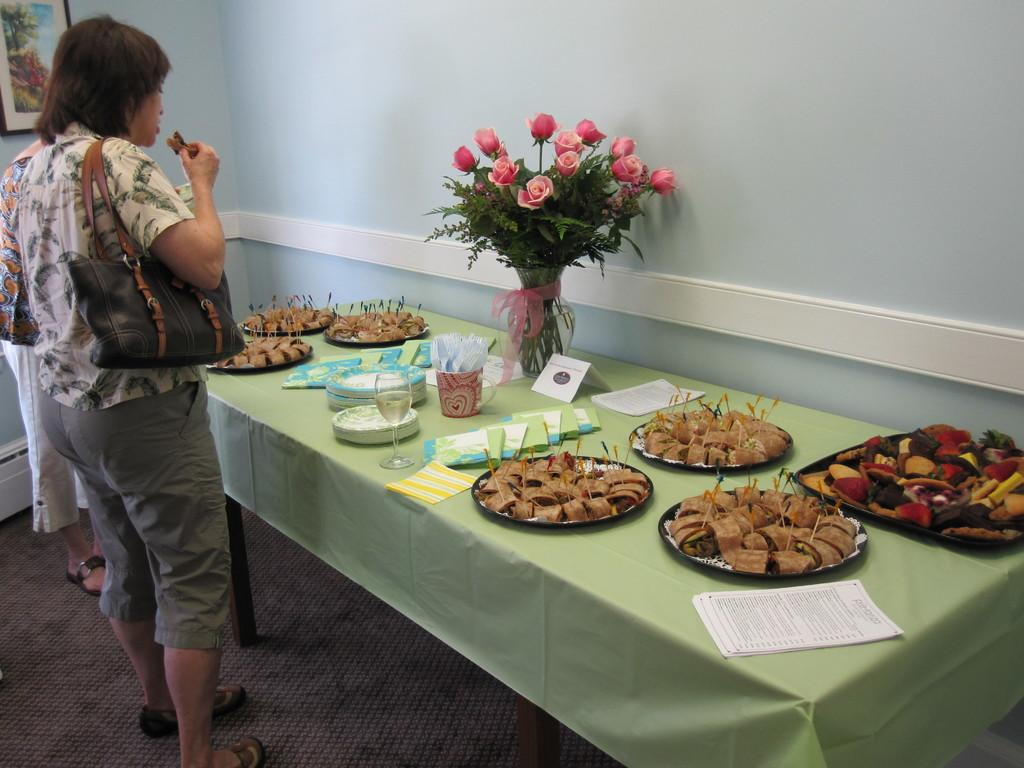Who is present in the image? There is a woman in the image. What is the woman doing in the image? The woman is standing. What is the woman holding in the image? The woman is holding a handbag. What can be seen on the table in the image? There is a plate, food, a glass, and a bouquet on the table. What type of rifle is the woman holding in the image? There is no rifle present in the image; the woman is holding a handbag. How many chairs are visible in the image? There is no mention of chairs in the provided facts, so we cannot determine the number of chairs in the image. 